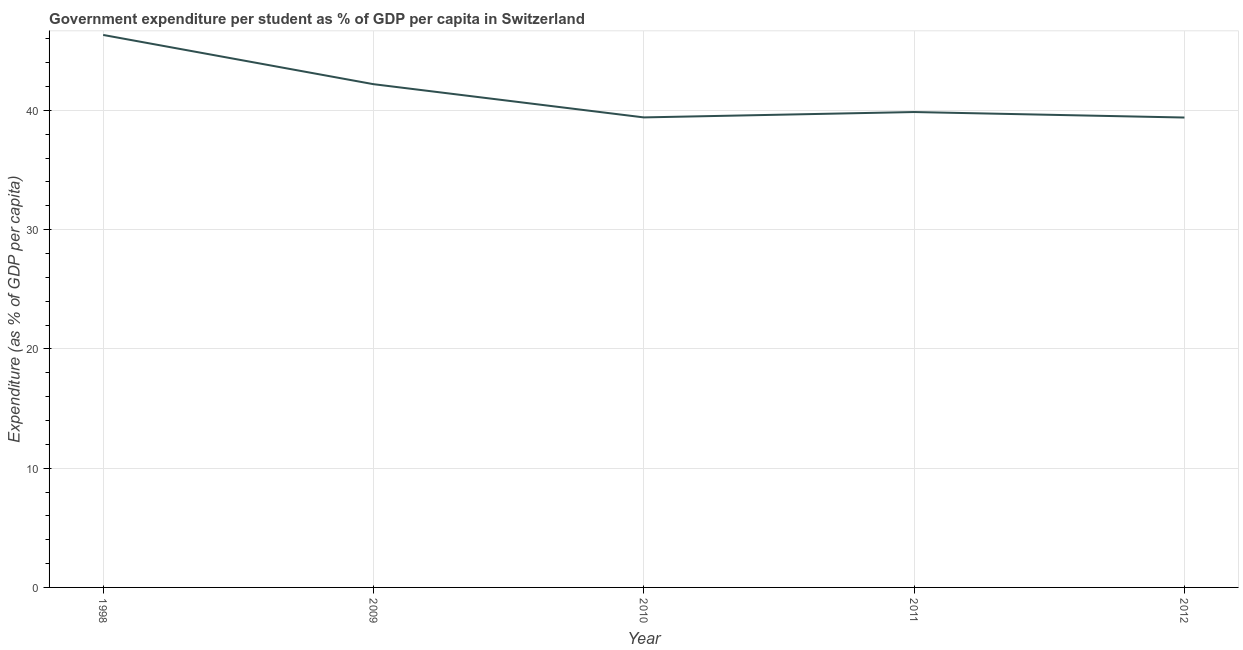What is the government expenditure per student in 2009?
Keep it short and to the point. 42.19. Across all years, what is the maximum government expenditure per student?
Make the answer very short. 46.32. Across all years, what is the minimum government expenditure per student?
Your answer should be compact. 39.4. In which year was the government expenditure per student maximum?
Give a very brief answer. 1998. In which year was the government expenditure per student minimum?
Offer a very short reply. 2012. What is the sum of the government expenditure per student?
Your answer should be very brief. 207.17. What is the difference between the government expenditure per student in 2009 and 2010?
Your answer should be very brief. 2.79. What is the average government expenditure per student per year?
Keep it short and to the point. 41.43. What is the median government expenditure per student?
Keep it short and to the point. 39.86. What is the ratio of the government expenditure per student in 2010 to that in 2011?
Your answer should be compact. 0.99. Is the government expenditure per student in 2010 less than that in 2012?
Your response must be concise. No. Is the difference between the government expenditure per student in 2009 and 2011 greater than the difference between any two years?
Keep it short and to the point. No. What is the difference between the highest and the second highest government expenditure per student?
Keep it short and to the point. 4.13. Is the sum of the government expenditure per student in 2010 and 2011 greater than the maximum government expenditure per student across all years?
Offer a very short reply. Yes. What is the difference between the highest and the lowest government expenditure per student?
Provide a succinct answer. 6.92. In how many years, is the government expenditure per student greater than the average government expenditure per student taken over all years?
Provide a short and direct response. 2. What is the difference between two consecutive major ticks on the Y-axis?
Provide a succinct answer. 10. Does the graph contain grids?
Make the answer very short. Yes. What is the title of the graph?
Offer a very short reply. Government expenditure per student as % of GDP per capita in Switzerland. What is the label or title of the X-axis?
Your response must be concise. Year. What is the label or title of the Y-axis?
Offer a very short reply. Expenditure (as % of GDP per capita). What is the Expenditure (as % of GDP per capita) in 1998?
Keep it short and to the point. 46.32. What is the Expenditure (as % of GDP per capita) in 2009?
Make the answer very short. 42.19. What is the Expenditure (as % of GDP per capita) in 2010?
Your response must be concise. 39.41. What is the Expenditure (as % of GDP per capita) of 2011?
Make the answer very short. 39.86. What is the Expenditure (as % of GDP per capita) in 2012?
Ensure brevity in your answer.  39.4. What is the difference between the Expenditure (as % of GDP per capita) in 1998 and 2009?
Provide a succinct answer. 4.13. What is the difference between the Expenditure (as % of GDP per capita) in 1998 and 2010?
Make the answer very short. 6.91. What is the difference between the Expenditure (as % of GDP per capita) in 1998 and 2011?
Offer a very short reply. 6.46. What is the difference between the Expenditure (as % of GDP per capita) in 1998 and 2012?
Make the answer very short. 6.92. What is the difference between the Expenditure (as % of GDP per capita) in 2009 and 2010?
Keep it short and to the point. 2.79. What is the difference between the Expenditure (as % of GDP per capita) in 2009 and 2011?
Provide a short and direct response. 2.33. What is the difference between the Expenditure (as % of GDP per capita) in 2009 and 2012?
Provide a short and direct response. 2.8. What is the difference between the Expenditure (as % of GDP per capita) in 2010 and 2011?
Ensure brevity in your answer.  -0.45. What is the difference between the Expenditure (as % of GDP per capita) in 2010 and 2012?
Your answer should be compact. 0.01. What is the difference between the Expenditure (as % of GDP per capita) in 2011 and 2012?
Your response must be concise. 0.46. What is the ratio of the Expenditure (as % of GDP per capita) in 1998 to that in 2009?
Your answer should be compact. 1.1. What is the ratio of the Expenditure (as % of GDP per capita) in 1998 to that in 2010?
Keep it short and to the point. 1.18. What is the ratio of the Expenditure (as % of GDP per capita) in 1998 to that in 2011?
Your answer should be very brief. 1.16. What is the ratio of the Expenditure (as % of GDP per capita) in 1998 to that in 2012?
Give a very brief answer. 1.18. What is the ratio of the Expenditure (as % of GDP per capita) in 2009 to that in 2010?
Give a very brief answer. 1.07. What is the ratio of the Expenditure (as % of GDP per capita) in 2009 to that in 2011?
Make the answer very short. 1.06. What is the ratio of the Expenditure (as % of GDP per capita) in 2009 to that in 2012?
Keep it short and to the point. 1.07. What is the ratio of the Expenditure (as % of GDP per capita) in 2010 to that in 2012?
Your answer should be compact. 1. 